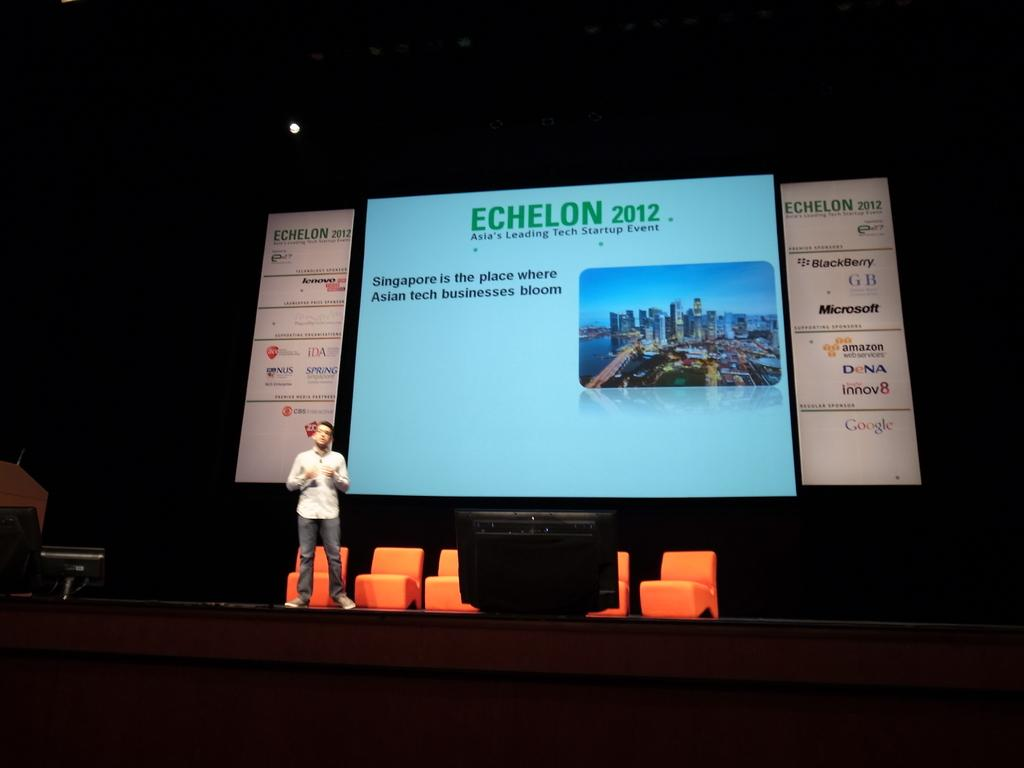<image>
Present a compact description of the photo's key features. A man on stage in front of a screen which reads "Echelon 2012". 